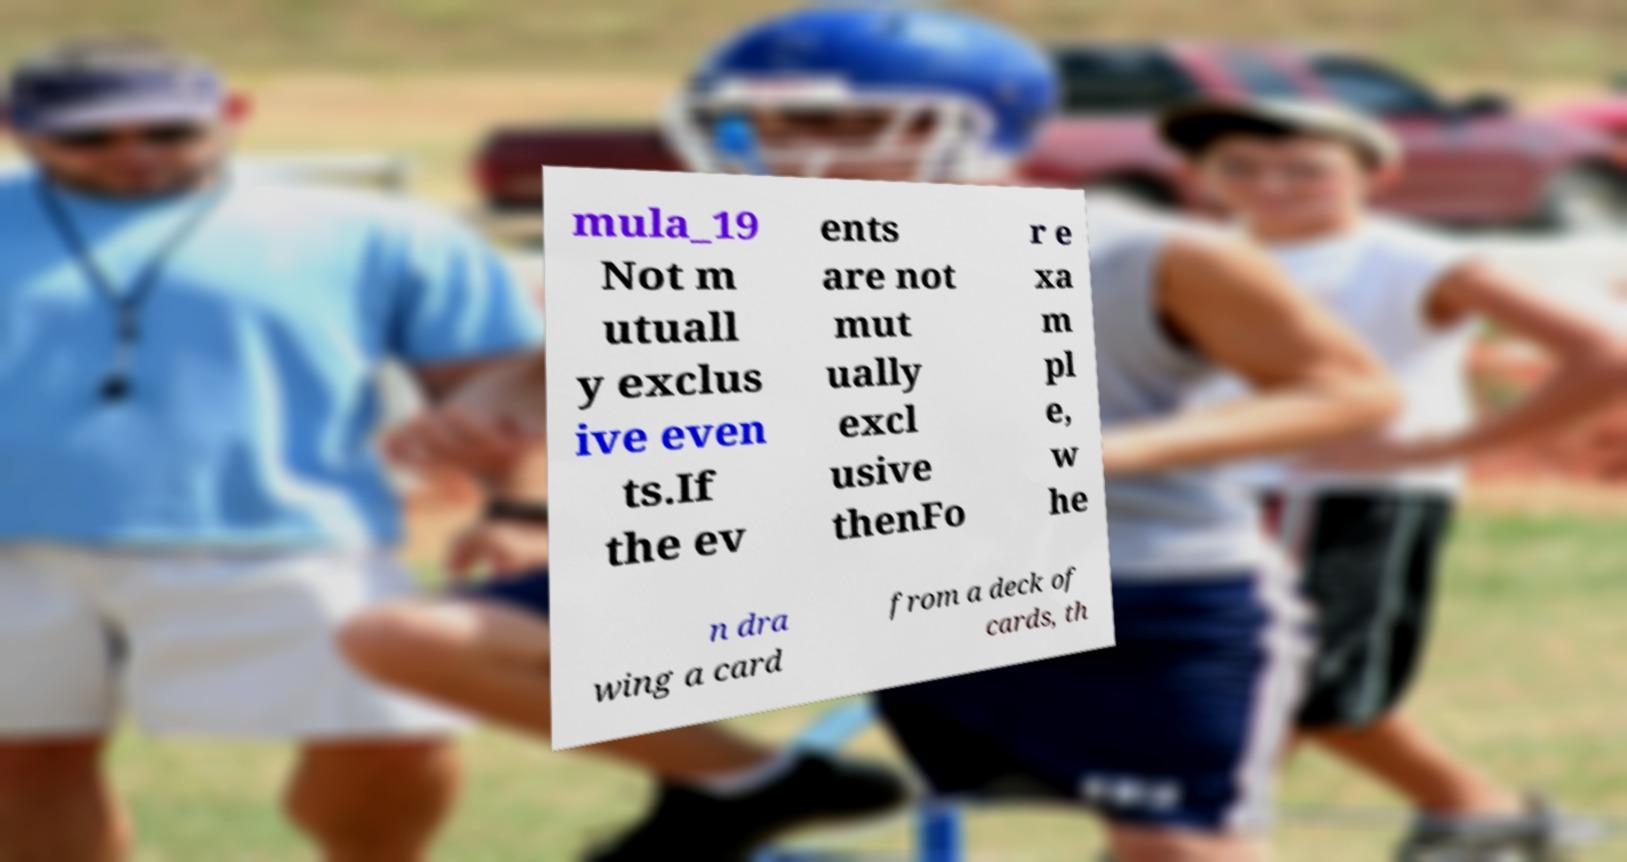There's text embedded in this image that I need extracted. Can you transcribe it verbatim? mula_19 Not m utuall y exclus ive even ts.If the ev ents are not mut ually excl usive thenFo r e xa m pl e, w he n dra wing a card from a deck of cards, th 